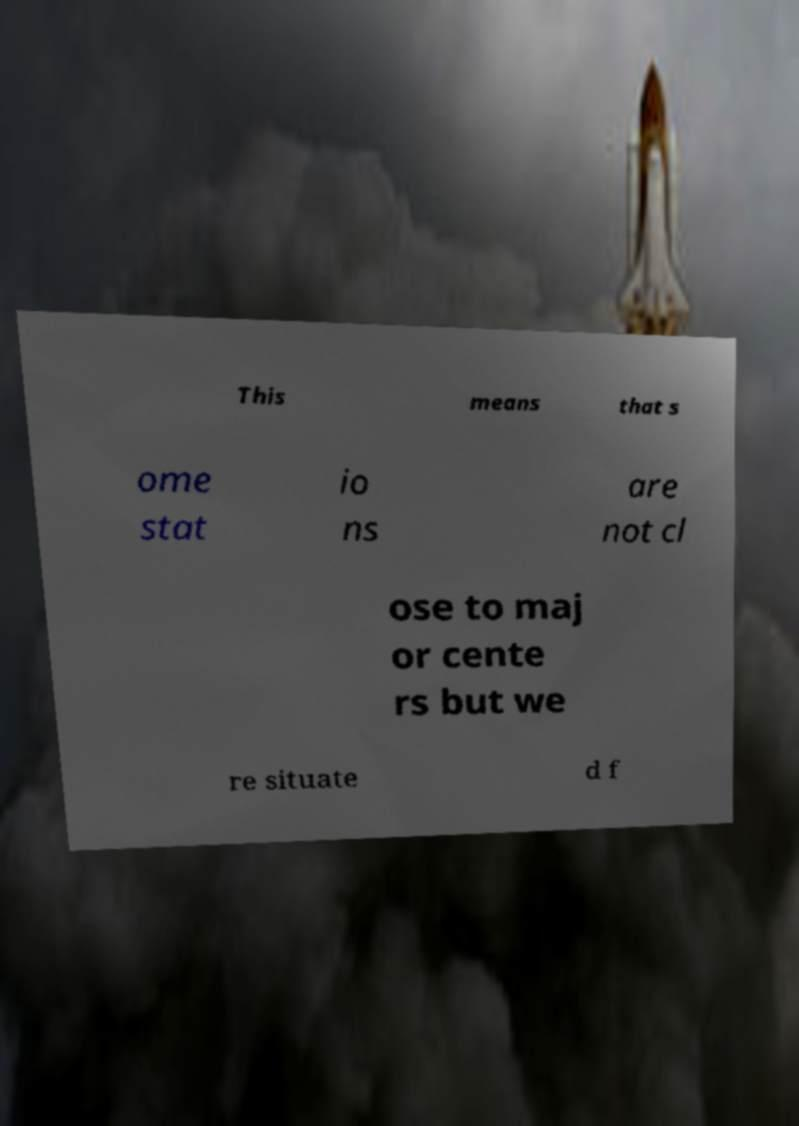I need the written content from this picture converted into text. Can you do that? This means that s ome stat io ns are not cl ose to maj or cente rs but we re situate d f 